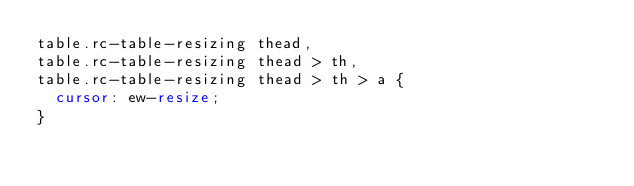Convert code to text. <code><loc_0><loc_0><loc_500><loc_500><_CSS_>table.rc-table-resizing thead,
table.rc-table-resizing thead > th,
table.rc-table-resizing thead > th > a {
  cursor: ew-resize;
}
</code> 